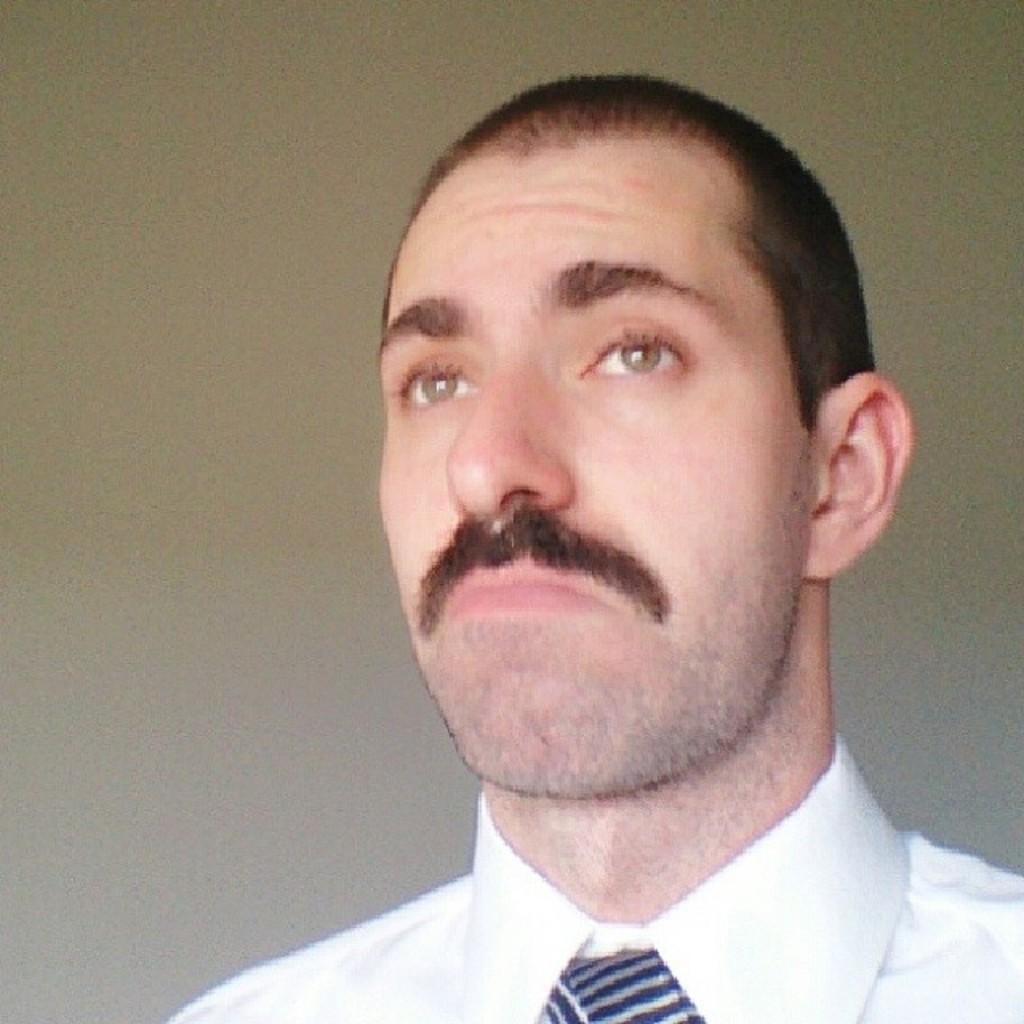Could you give a brief overview of what you see in this image? In the foreground of this image, there is a man wearing white shirt and a tie. In the background, there is a wall. 